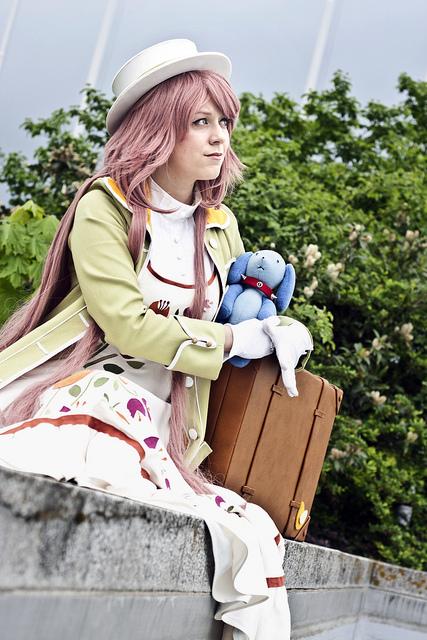Is the lady wearing a hat?
Be succinct. Yes. Does she look happy to be in a photo?
Quick response, please. Yes. What color is her doll?
Concise answer only. Blue. 